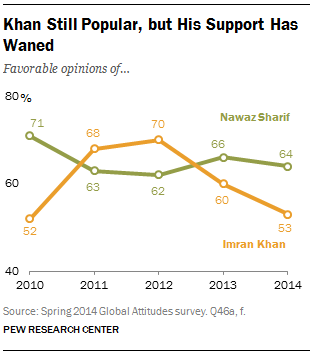Point out several critical features in this image. The highest value of the green color bar is 71. I am not sure what you are asking. Could you please provide more context or clarify your question? 